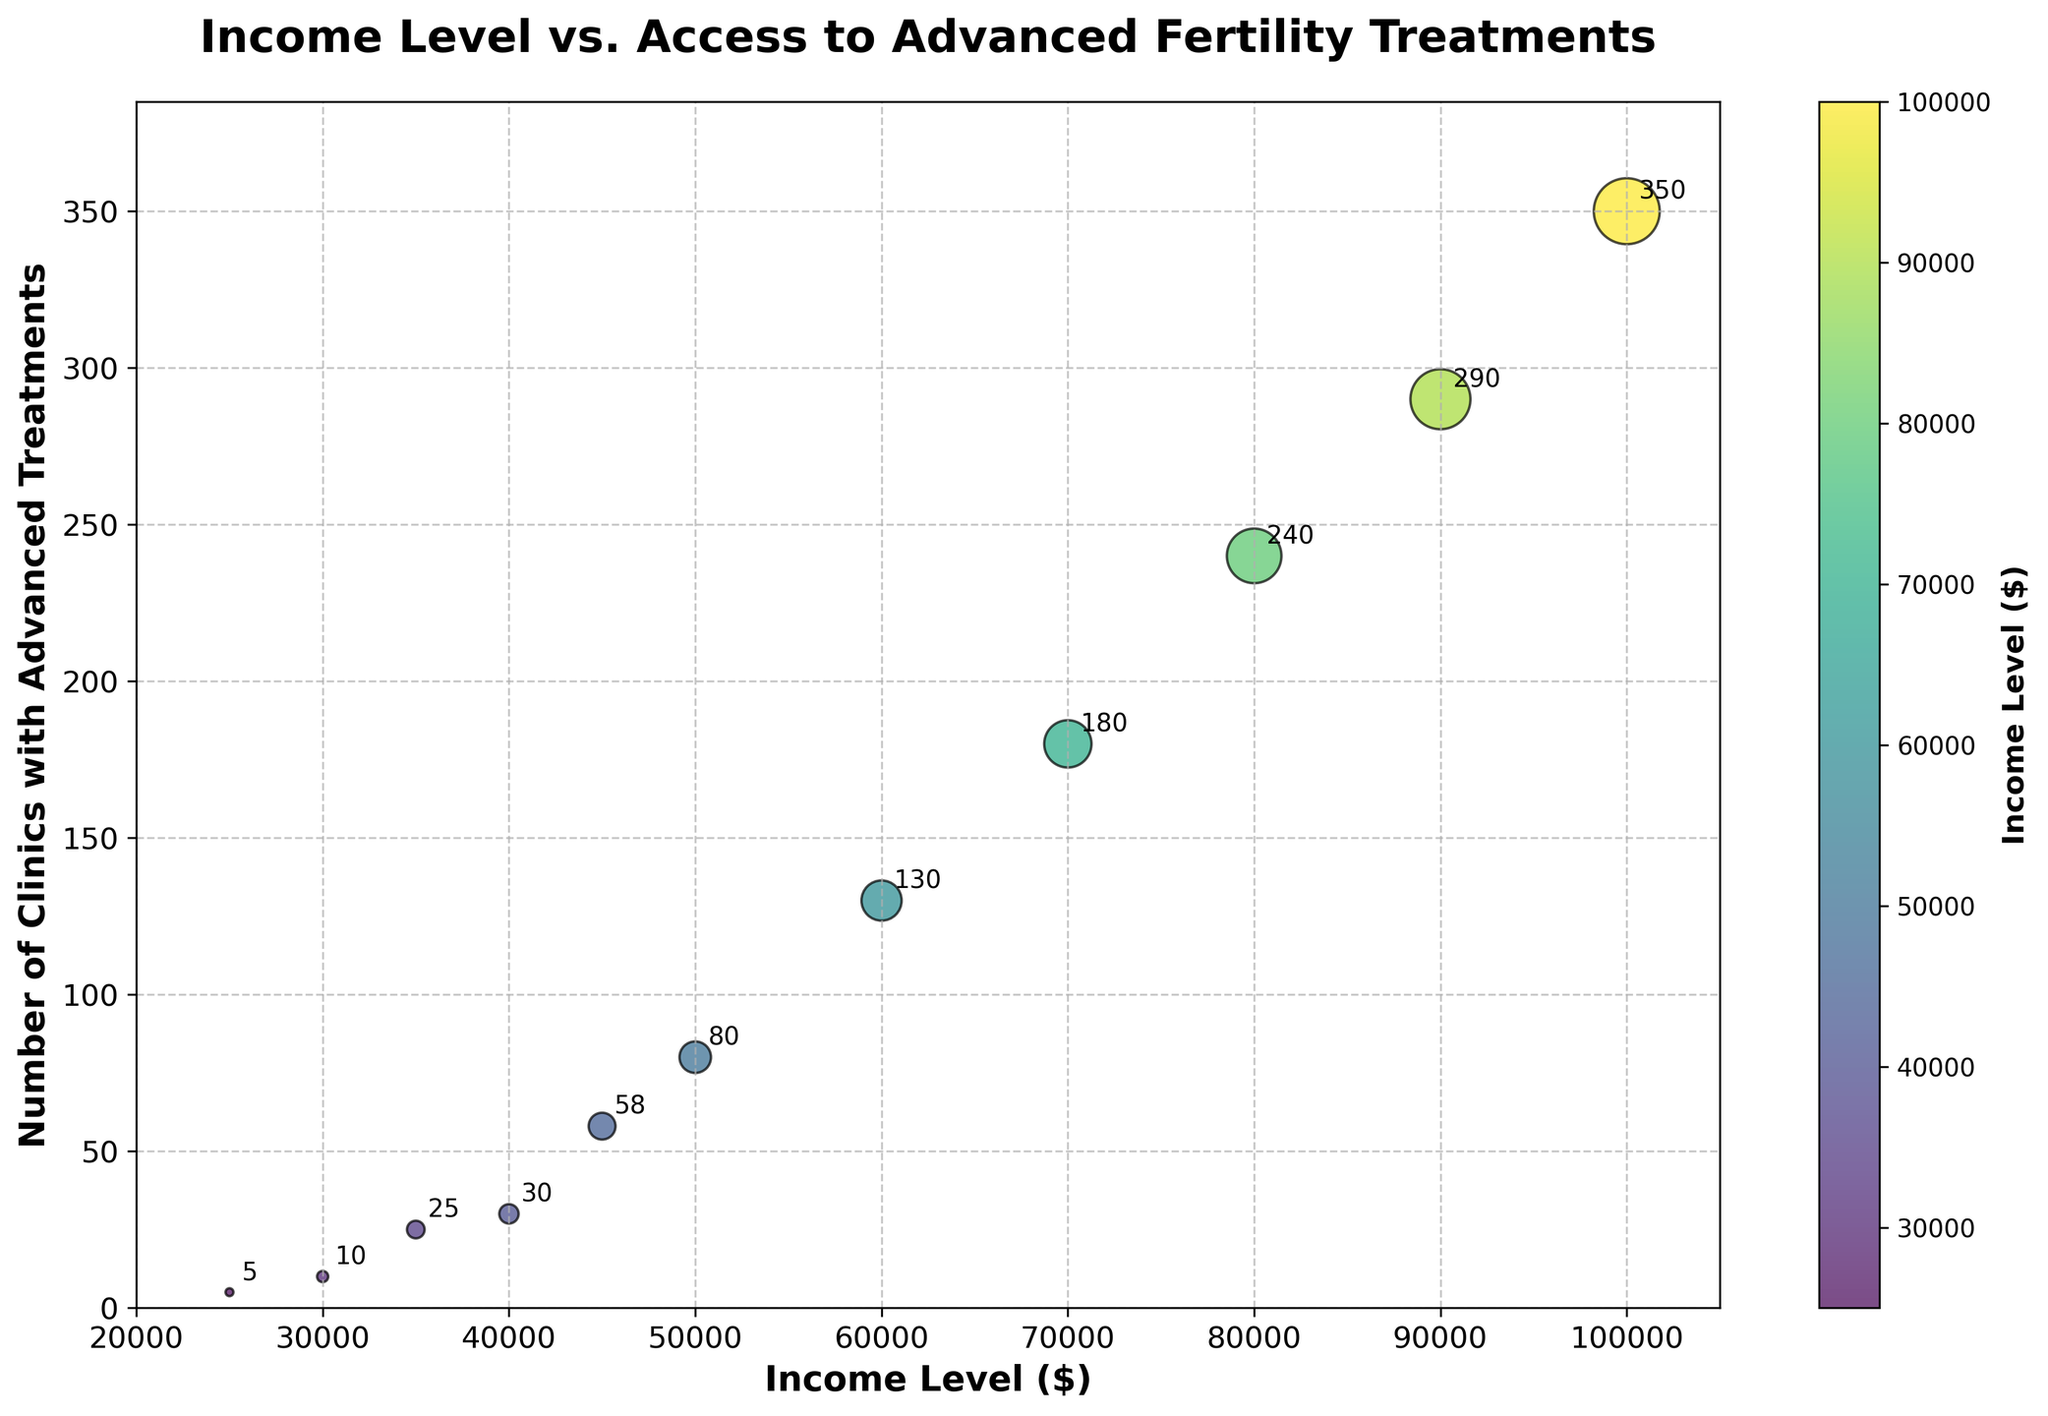what is the title of the figure? The title is prominently shown at the top of the figure. It reads "Income Level vs. Access to Advanced Fertility Treatments".
Answer: Income Level vs. Access to Advanced Fertility Treatments How many data points are plotted in the figure? Each pair of income level and number of clinics with advanced treatments represents a data point. Counting these pairs in the data gives us 11 data points.
Answer: 11 What is the range of income levels shown on the x-axis? The x-axis represents income levels, starting from 20000 and extending to 105000 as indicated by the limit set on the axis.
Answer: 20000 to 105000 What is the highest number of clinics with advanced treatments available for any income level, and at what income level is this observed? By looking at the y-axis and the annotations, the highest number of clinics is 350, observed at the $100,000 income level.
Answer: 350, at $100,000 Is there a general trend observed between income level and access to advanced fertility treatments? Observing the scatter plot, the number of clinics with advanced treatments increases as the income level increases, indicating a positive correlation between income and access.
Answer: Positive correlation At an income level of $50,000, how many clinics with advanced treatments are available? Referring to the data points, at an income level of $50,000, the number of clinics with advanced treatments is 80.
Answer: 80 Which income level has the smallest number of clinics with advanced treatments, and how many clinics are there? By looking at the lowest y-axis value and corresponding x-axis values, the smallest number of clinics is 5, observed at the $25,000 income level.
Answer: $25,000, 5 What is the difference in the number of clinics between income levels of $70,000 and $40,000? At $70,000 the number of clinics is 180, and at $40,000 the number is 30. The difference is 180 - 30 = 150.
Answer: 150 How does the number of clinics with advanced treatments change as income level increases from $40,000 to $60,000? At $40,000 there are 30 clinics, and it increases to 130 clinics at $60,000. The number of clinics increases by 100 as income level rises from $40,000 to $60,000.
Answer: Increases by 100 Which income level shows a stark increase in the number of clinics compared to the previous income level? Observing the data points for steep changes, a noticeable increase is between $45,000 (58 clinics) and $50,000 (80 clinics), rising further between $50,000 (80 clinics) and $60,000 (130 clinics).
Answer: Between $50,000 and $60,000 